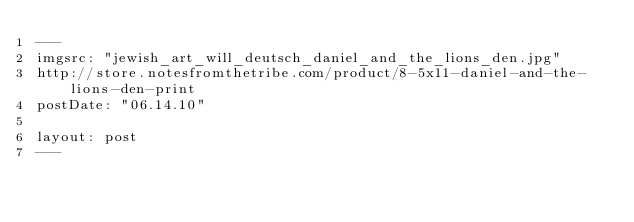<code> <loc_0><loc_0><loc_500><loc_500><_HTML_>---
imgsrc: "jewish_art_will_deutsch_daniel_and_the_lions_den.jpg"
http://store.notesfromthetribe.com/product/8-5x11-daniel-and-the-lions-den-print
postDate: "06.14.10"

layout: post
---</code> 